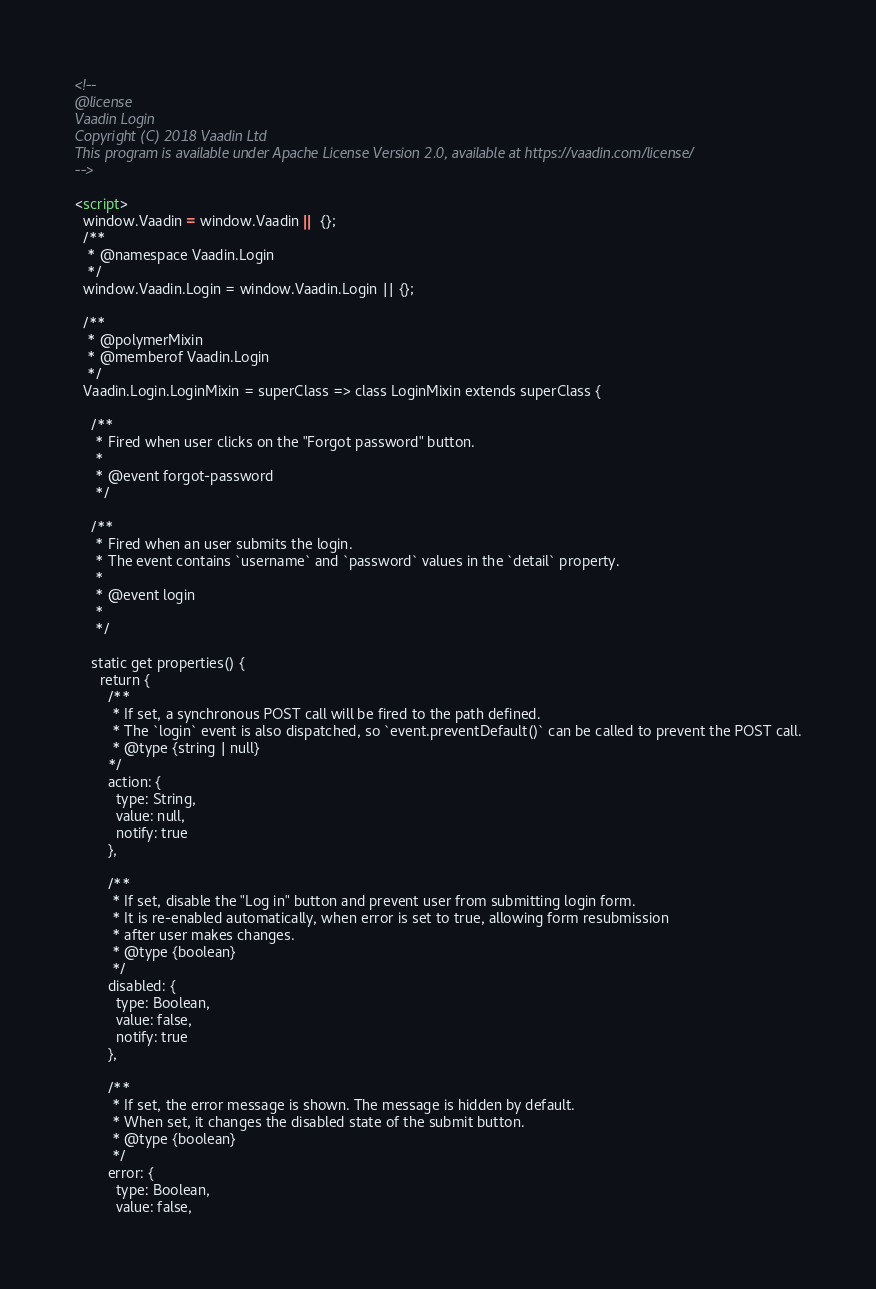<code> <loc_0><loc_0><loc_500><loc_500><_HTML_><!--
@license
Vaadin Login
Copyright (C) 2018 Vaadin Ltd
This program is available under Apache License Version 2.0, available at https://vaadin.com/license/
-->

<script>
  window.Vaadin = window.Vaadin || {};
  /**
   * @namespace Vaadin.Login
   */
  window.Vaadin.Login = window.Vaadin.Login || {};

  /**
   * @polymerMixin
   * @memberof Vaadin.Login
   */
  Vaadin.Login.LoginMixin = superClass => class LoginMixin extends superClass {

    /**
     * Fired when user clicks on the "Forgot password" button.
     *
     * @event forgot-password
     */

    /**
     * Fired when an user submits the login.
     * The event contains `username` and `password` values in the `detail` property.
     *
     * @event login
     *
     */

    static get properties() {
      return {
        /**
         * If set, a synchronous POST call will be fired to the path defined.
         * The `login` event is also dispatched, so `event.preventDefault()` can be called to prevent the POST call.
         * @type {string | null}
        */
        action: {
          type: String,
          value: null,
          notify: true
        },

        /**
         * If set, disable the "Log in" button and prevent user from submitting login form.
         * It is re-enabled automatically, when error is set to true, allowing form resubmission
         * after user makes changes.
         * @type {boolean}
         */
        disabled: {
          type: Boolean,
          value: false,
          notify: true
        },

        /**
         * If set, the error message is shown. The message is hidden by default.
         * When set, it changes the disabled state of the submit button.
         * @type {boolean}
         */
        error: {
          type: Boolean,
          value: false,</code> 